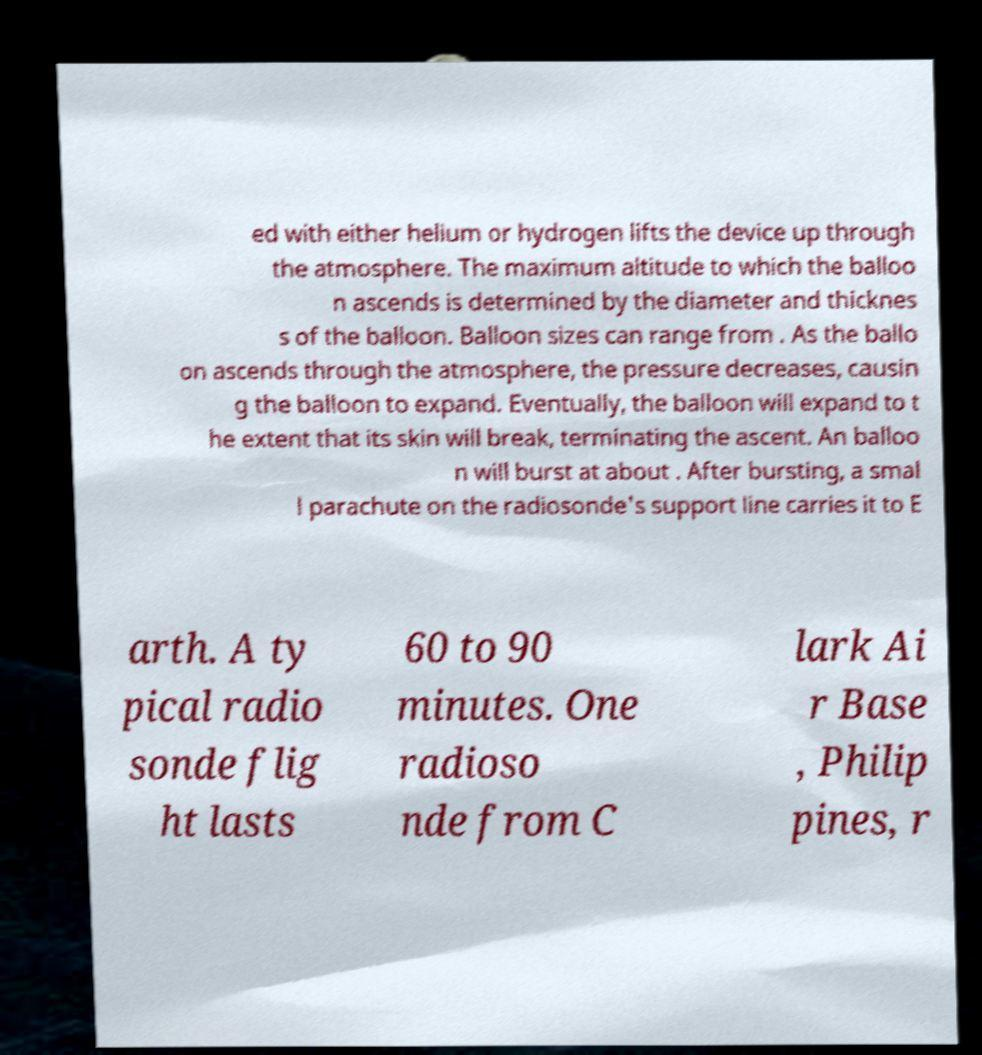There's text embedded in this image that I need extracted. Can you transcribe it verbatim? ed with either helium or hydrogen lifts the device up through the atmosphere. The maximum altitude to which the balloo n ascends is determined by the diameter and thicknes s of the balloon. Balloon sizes can range from . As the ballo on ascends through the atmosphere, the pressure decreases, causin g the balloon to expand. Eventually, the balloon will expand to t he extent that its skin will break, terminating the ascent. An balloo n will burst at about . After bursting, a smal l parachute on the radiosonde's support line carries it to E arth. A ty pical radio sonde flig ht lasts 60 to 90 minutes. One radioso nde from C lark Ai r Base , Philip pines, r 